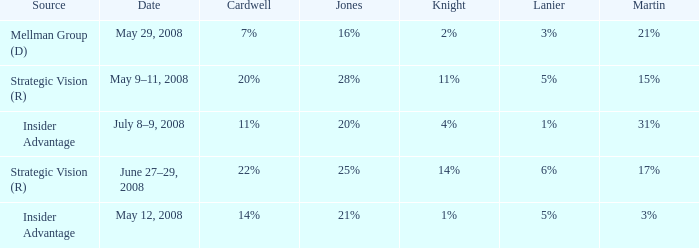What source has a Knight of 2%? Mellman Group (D). 